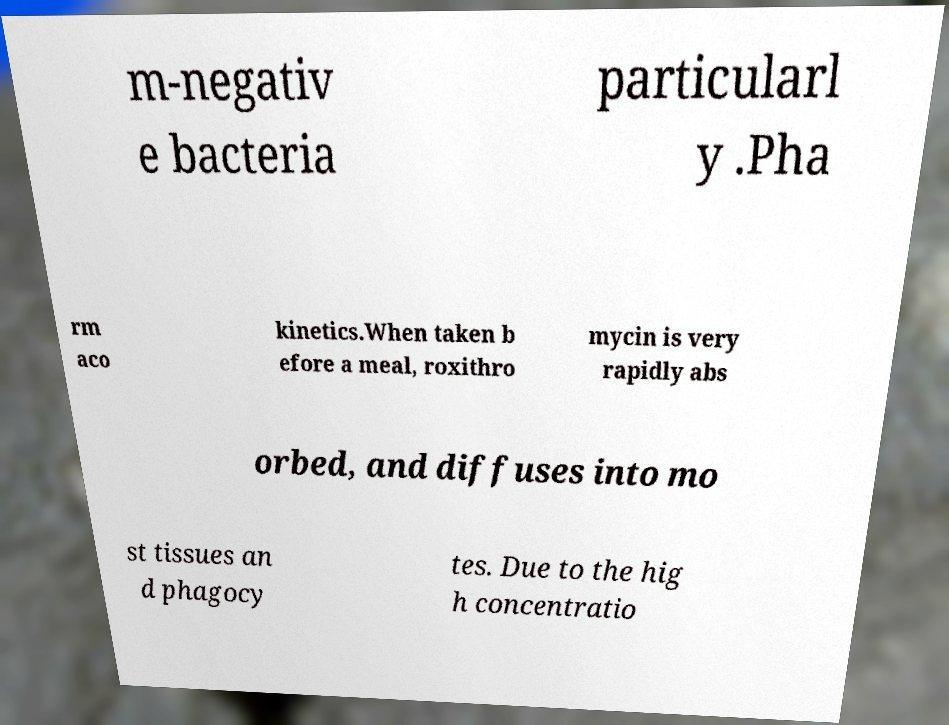I need the written content from this picture converted into text. Can you do that? m-negativ e bacteria particularl y .Pha rm aco kinetics.When taken b efore a meal, roxithro mycin is very rapidly abs orbed, and diffuses into mo st tissues an d phagocy tes. Due to the hig h concentratio 